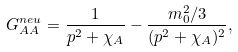Convert formula to latex. <formula><loc_0><loc_0><loc_500><loc_500>G _ { A A } ^ { n e u } = \frac { 1 } { p ^ { 2 } + \chi _ { A } } - \frac { m _ { 0 } ^ { 2 } / 3 } { ( p ^ { 2 } + \chi _ { A } ) ^ { 2 } } ,</formula> 